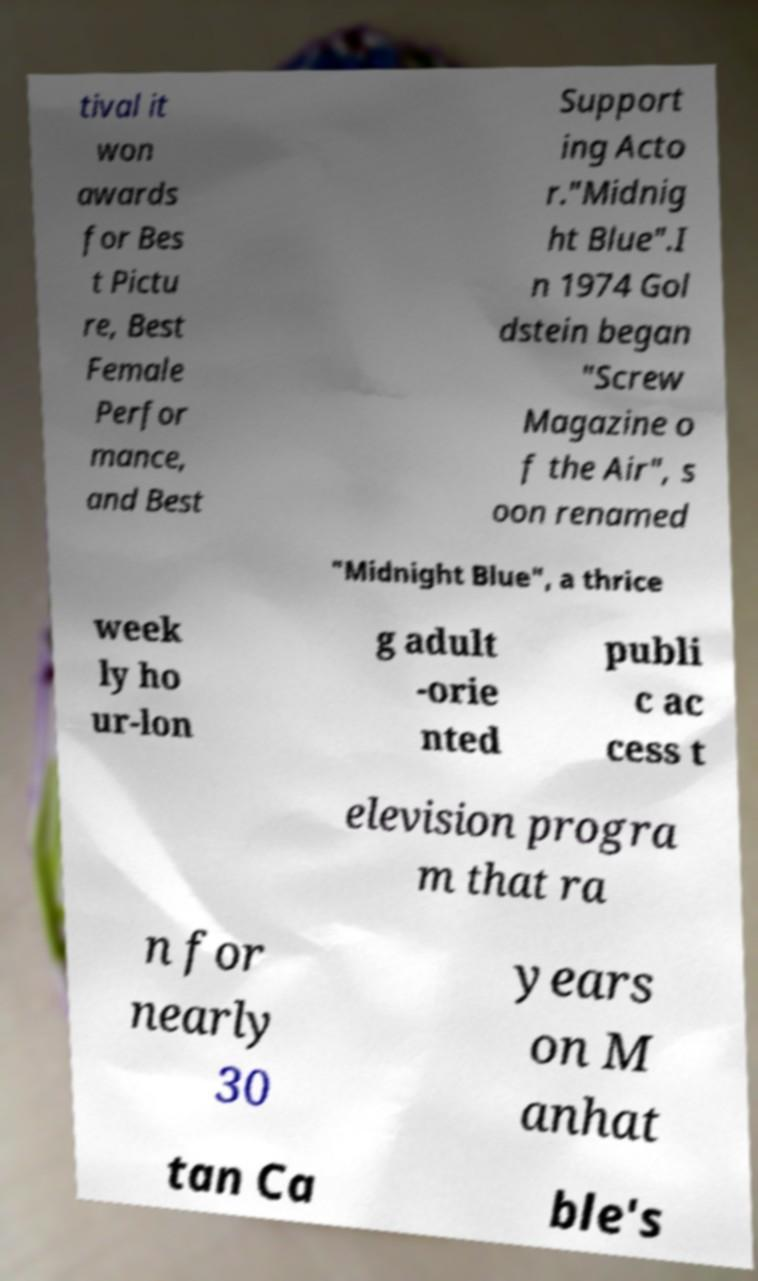Can you read and provide the text displayed in the image?This photo seems to have some interesting text. Can you extract and type it out for me? tival it won awards for Bes t Pictu re, Best Female Perfor mance, and Best Support ing Acto r."Midnig ht Blue".I n 1974 Gol dstein began "Screw Magazine o f the Air", s oon renamed "Midnight Blue", a thrice week ly ho ur-lon g adult -orie nted publi c ac cess t elevision progra m that ra n for nearly 30 years on M anhat tan Ca ble's 